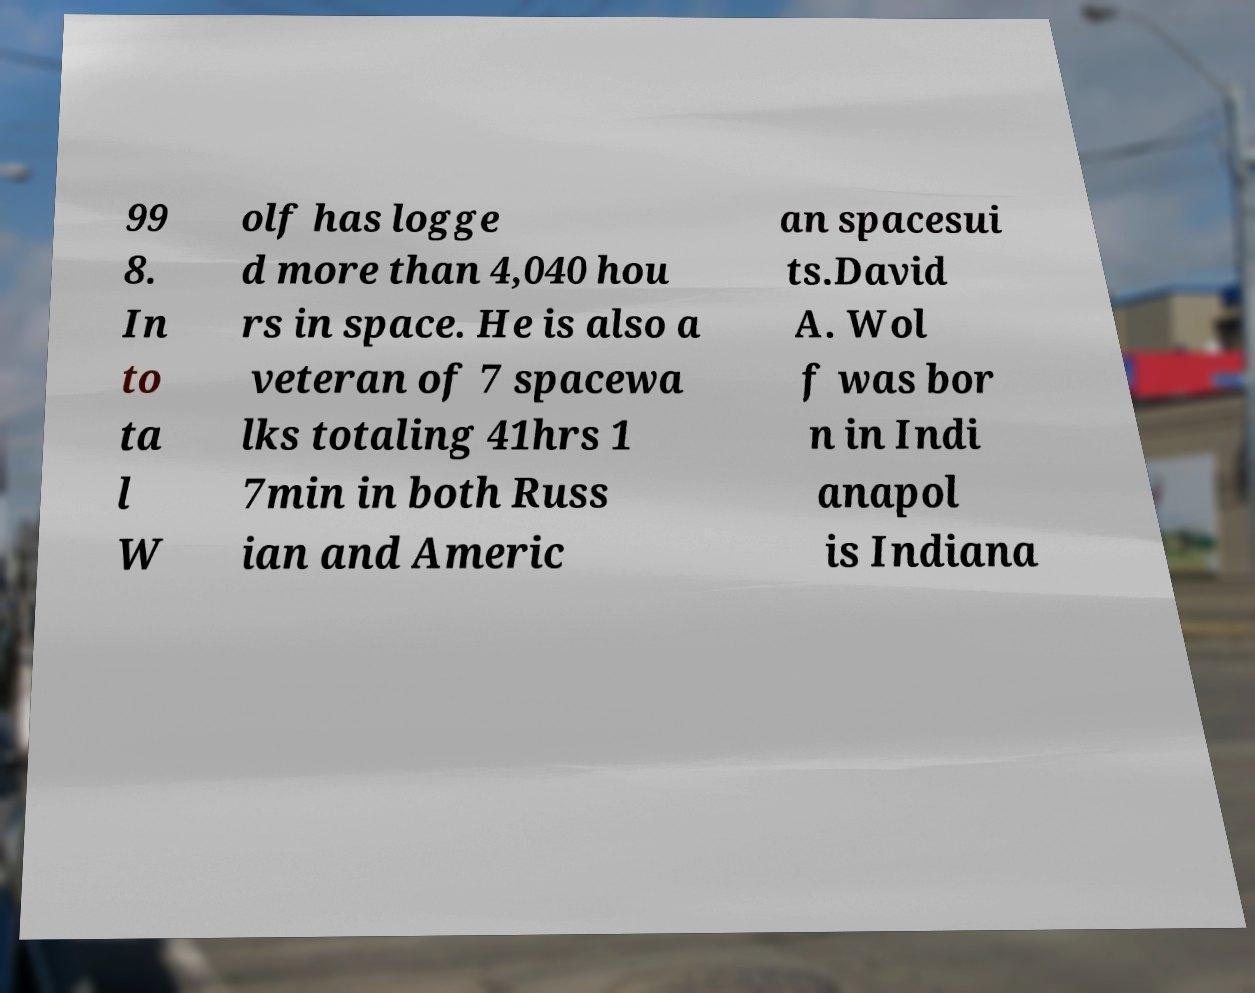For documentation purposes, I need the text within this image transcribed. Could you provide that? 99 8. In to ta l W olf has logge d more than 4,040 hou rs in space. He is also a veteran of 7 spacewa lks totaling 41hrs 1 7min in both Russ ian and Americ an spacesui ts.David A. Wol f was bor n in Indi anapol is Indiana 